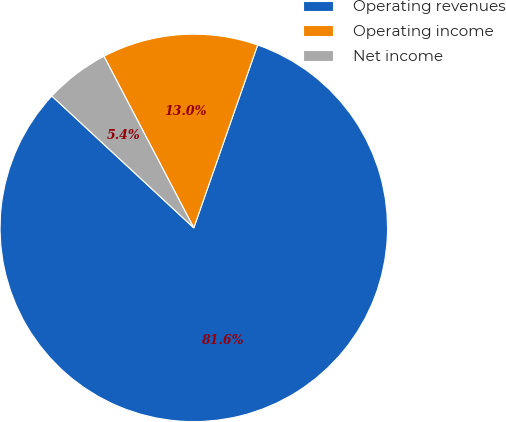<chart> <loc_0><loc_0><loc_500><loc_500><pie_chart><fcel>Operating revenues<fcel>Operating income<fcel>Net income<nl><fcel>81.57%<fcel>13.02%<fcel>5.41%<nl></chart> 